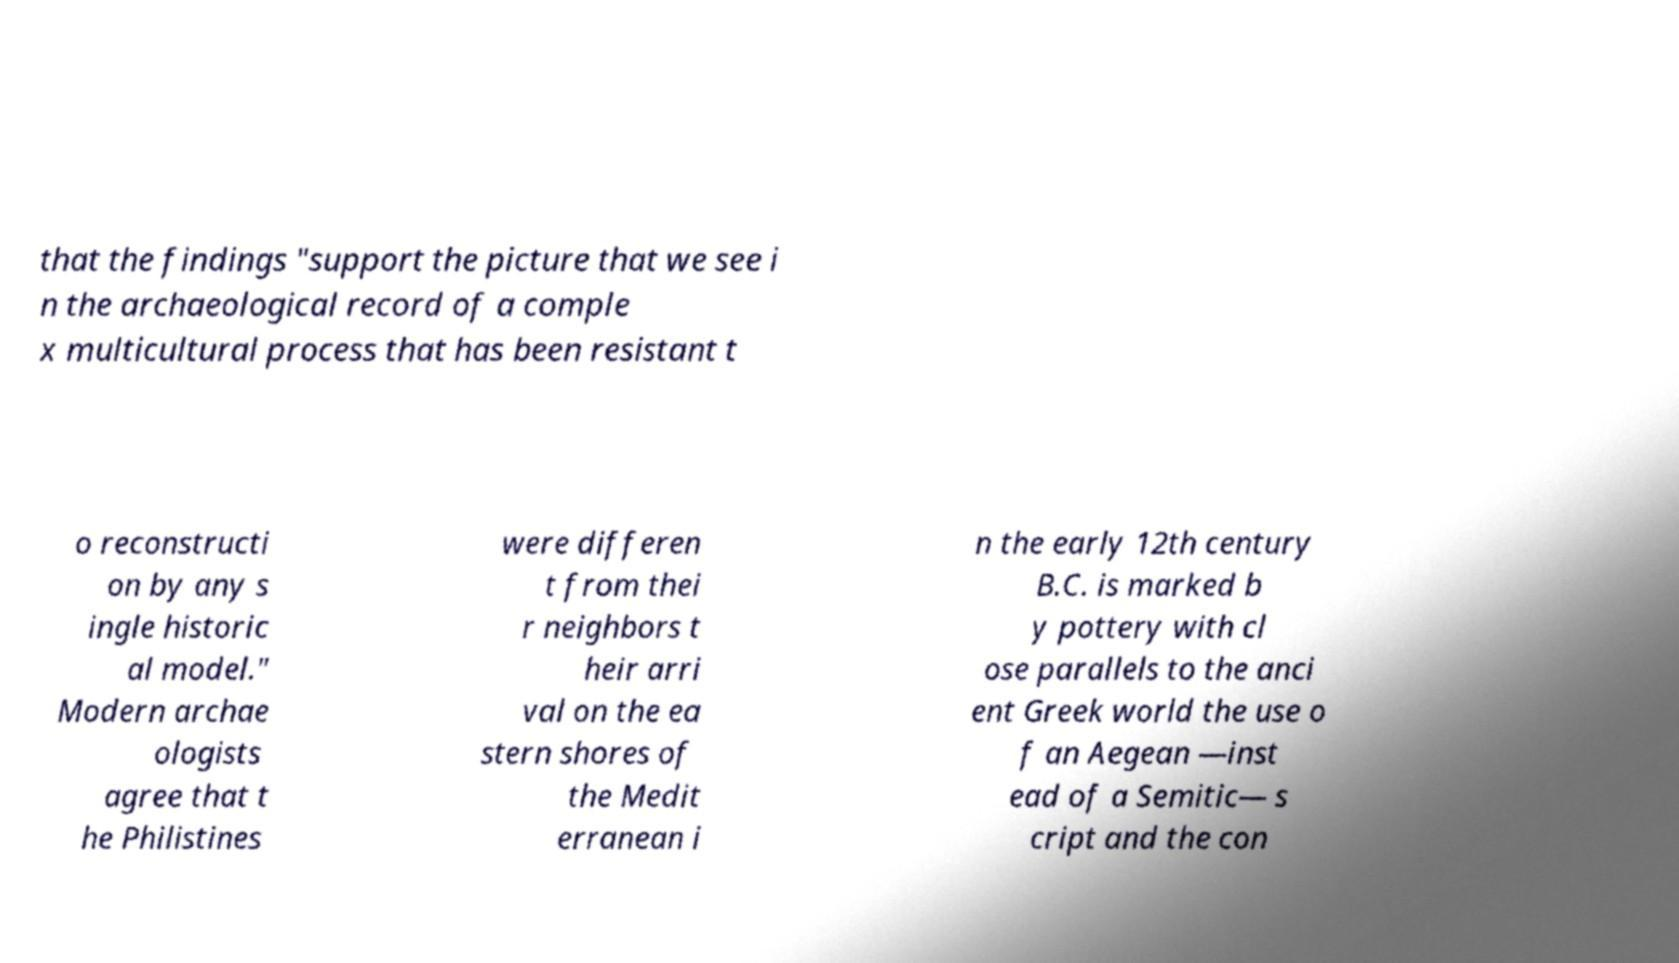Can you accurately transcribe the text from the provided image for me? that the findings "support the picture that we see i n the archaeological record of a comple x multicultural process that has been resistant t o reconstructi on by any s ingle historic al model." Modern archae ologists agree that t he Philistines were differen t from thei r neighbors t heir arri val on the ea stern shores of the Medit erranean i n the early 12th century B.C. is marked b y pottery with cl ose parallels to the anci ent Greek world the use o f an Aegean —inst ead of a Semitic— s cript and the con 